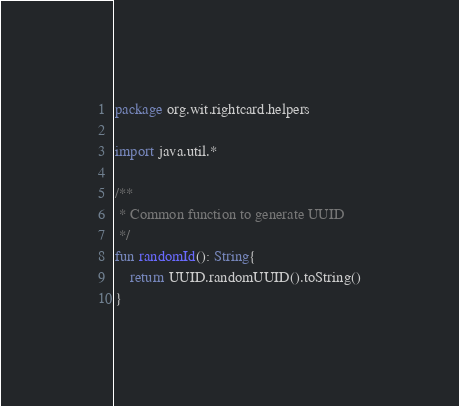<code> <loc_0><loc_0><loc_500><loc_500><_Kotlin_>package org.wit.rightcard.helpers

import java.util.*

/**
 * Common function to generate UUID
 */
fun randomId(): String{
    return UUID.randomUUID().toString()
}</code> 